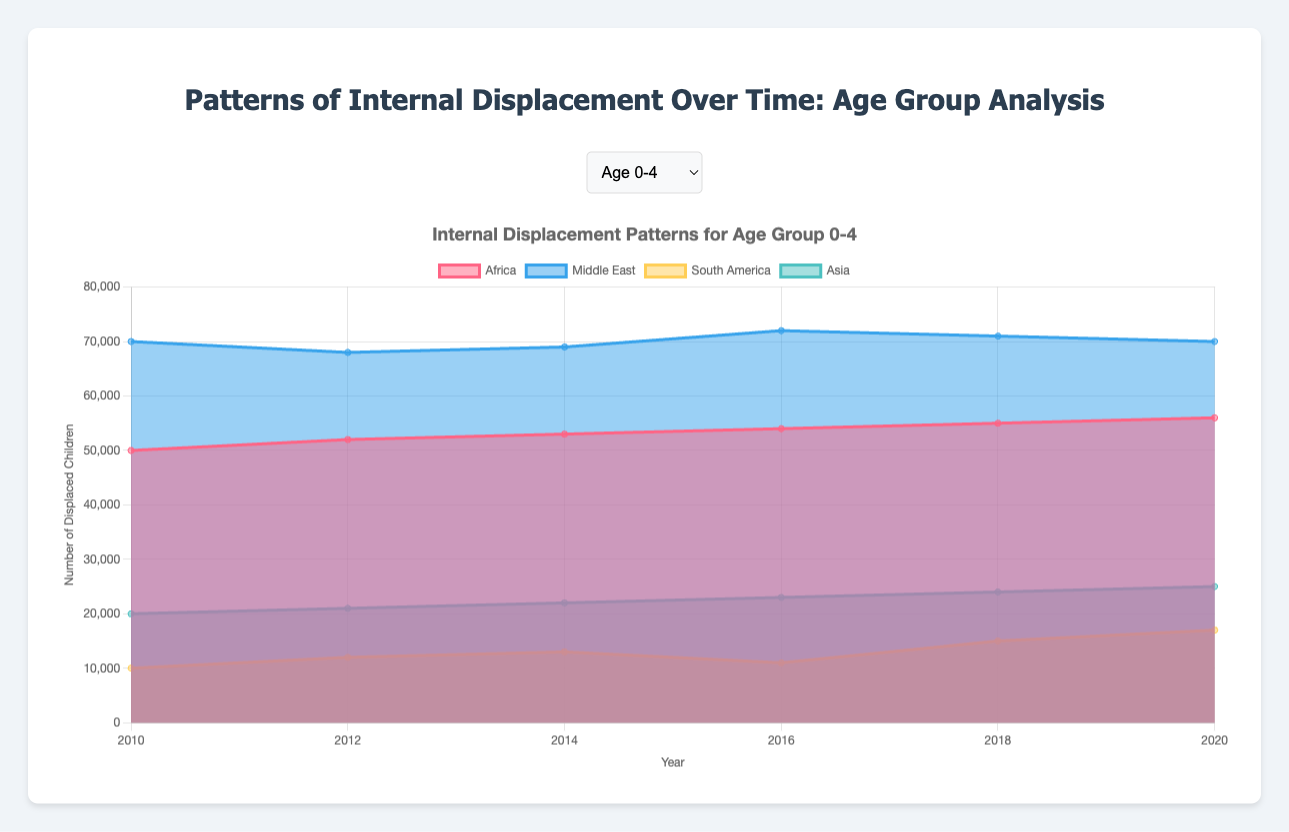What's the title of the chart? The title of the chart is usually displayed at the top. Here, it's stated at the top as "Patterns of Internal Displacement Over Time: Age Group Analysis".
Answer: Patterns of Internal Displacement Over Time: Age Group Analysis What is the vertical axis representing? The vertical axis typically represents the quantity being measured, as annotated in the chart. Here, it is "Number of Displaced Children".
Answer: Number of Displaced Children Comparing the years 2010 and 2020, how has the displacement trend in the 0-4 age group in Africa changed? To determine the change, observe the data values for 2010 and 2020 for the 0-4 age group in Africa. In 2010, the value is 50,000, and in 2020, it is 56,000. Thus, there is an increase over the years.
Answer: Increase Which region has the highest displacement for age group 10-14 in 2020? Look at the data for 2020 in the age group 10-14 for the different regions. The region with the highest value is the Middle East with 80,000 displacements.
Answer: Middle East What trend do we observe in the 5-9 age group in the Middle East from 2010 to 2020? Review the displacement numbers for the 5-9 age group in the Middle East across the years. Notice how the values go: 80,000 (2010), 77,000 (2012), 76,000 (2014), 75,000 (2016), 74,000 (2018), 73,000 (2020). The trend shows a gradual decline.
Answer: Gradual decline For the age group 15-19, which region shows a consistent increase in displacement over the period? An increase in displacement for the 15-19 age group is noted when values increment periodically. Africa is the region showing a consistent increase: 75,000 (2010) to 80,000 (2020).
Answer: Africa What is the overall trend of displacement for the 10-14 age group in South America from 2010 to 2020? Analyzing the values for South America within the age group 10-14 over the years provided: 14,000 (2010), 16,000 (2012), 17,000 (2014), 15,000 (2016), 19,000 (2018), 21,000 (2020) shows an overall increasing trend despite some fluctuations.
Answer: Increasing trend What is the mean displacement in Asia for the age group 0-4 across the given years? Average the values for Asia in the 0-4 age group: (20,000 + 21,000 + 22,000 + 23,000 + 24,000 + 25,000) / 6 = 22,500.
Answer: 22,500 